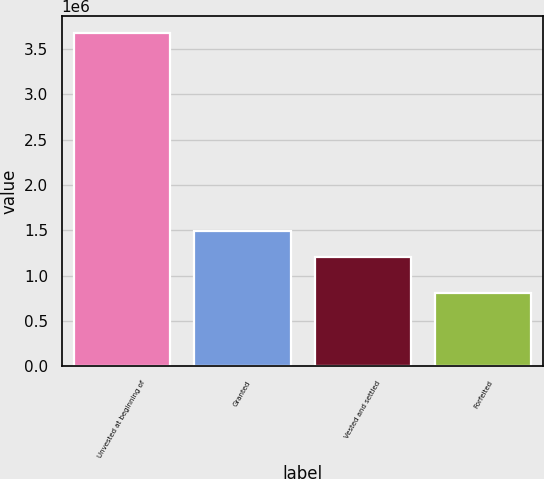Convert chart. <chart><loc_0><loc_0><loc_500><loc_500><bar_chart><fcel>Unvested at beginning of<fcel>Granted<fcel>Vested and settled<fcel>Forfeited<nl><fcel>3.67879e+06<fcel>1.49387e+06<fcel>1.20674e+06<fcel>807550<nl></chart> 